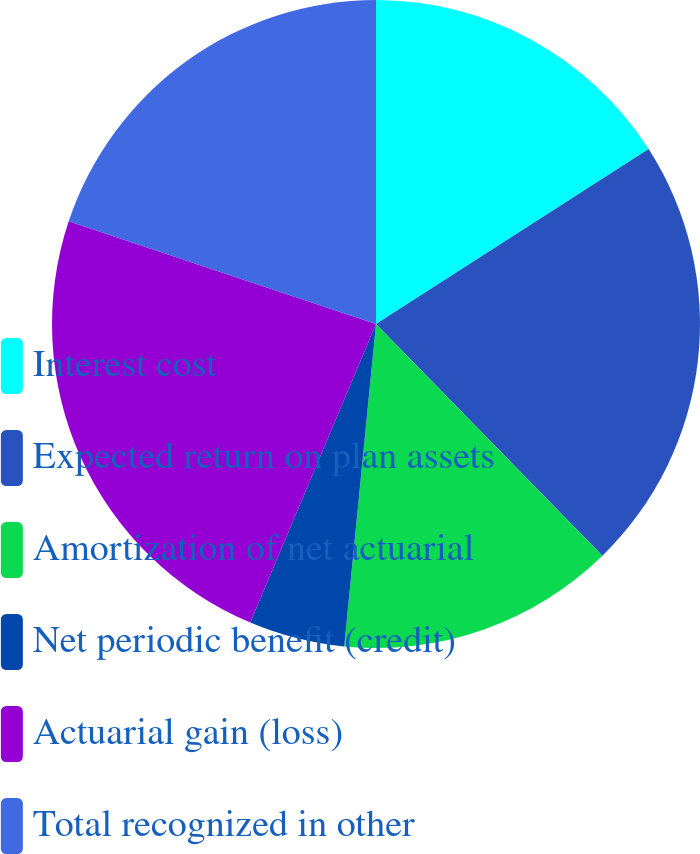<chart> <loc_0><loc_0><loc_500><loc_500><pie_chart><fcel>Interest cost<fcel>Expected return on plan assets<fcel>Amortization of net actuarial<fcel>Net periodic benefit (credit)<fcel>Actuarial gain (loss)<fcel>Total recognized in other<nl><fcel>15.92%<fcel>21.77%<fcel>13.88%<fcel>4.78%<fcel>23.79%<fcel>19.87%<nl></chart> 